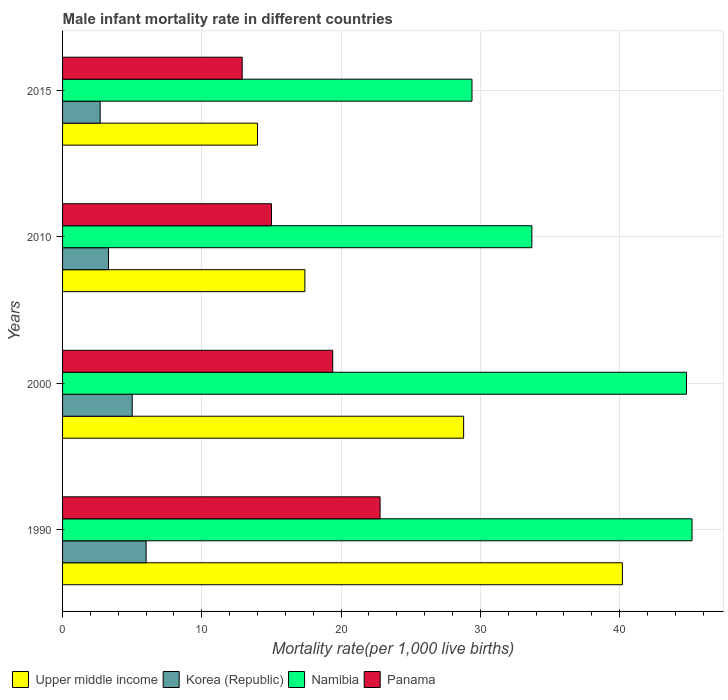How many different coloured bars are there?
Make the answer very short. 4. Are the number of bars per tick equal to the number of legend labels?
Give a very brief answer. Yes. How many bars are there on the 4th tick from the top?
Ensure brevity in your answer.  4. How many bars are there on the 1st tick from the bottom?
Keep it short and to the point. 4. In how many cases, is the number of bars for a given year not equal to the number of legend labels?
Give a very brief answer. 0. What is the male infant mortality rate in Namibia in 2000?
Your response must be concise. 44.8. Across all years, what is the maximum male infant mortality rate in Panama?
Give a very brief answer. 22.8. In which year was the male infant mortality rate in Upper middle income minimum?
Offer a very short reply. 2015. What is the total male infant mortality rate in Korea (Republic) in the graph?
Provide a short and direct response. 17. What is the difference between the male infant mortality rate in Namibia in 2000 and that in 2010?
Offer a terse response. 11.1. What is the difference between the male infant mortality rate in Panama in 2010 and the male infant mortality rate in Namibia in 2015?
Your answer should be very brief. -14.4. What is the average male infant mortality rate in Upper middle income per year?
Make the answer very short. 25.1. In the year 1990, what is the difference between the male infant mortality rate in Namibia and male infant mortality rate in Panama?
Give a very brief answer. 22.4. In how many years, is the male infant mortality rate in Upper middle income greater than 38 ?
Your answer should be very brief. 1. What is the ratio of the male infant mortality rate in Upper middle income in 1990 to that in 2015?
Keep it short and to the point. 2.87. Is the male infant mortality rate in Korea (Republic) in 1990 less than that in 2015?
Ensure brevity in your answer.  No. Is the difference between the male infant mortality rate in Namibia in 2000 and 2015 greater than the difference between the male infant mortality rate in Panama in 2000 and 2015?
Give a very brief answer. Yes. What is the difference between the highest and the second highest male infant mortality rate in Korea (Republic)?
Provide a succinct answer. 1. What is the difference between the highest and the lowest male infant mortality rate in Panama?
Offer a terse response. 9.9. In how many years, is the male infant mortality rate in Korea (Republic) greater than the average male infant mortality rate in Korea (Republic) taken over all years?
Your answer should be compact. 2. Is the sum of the male infant mortality rate in Korea (Republic) in 1990 and 2010 greater than the maximum male infant mortality rate in Panama across all years?
Provide a succinct answer. No. What does the 1st bar from the top in 2015 represents?
Keep it short and to the point. Panama. What does the 1st bar from the bottom in 2010 represents?
Keep it short and to the point. Upper middle income. Is it the case that in every year, the sum of the male infant mortality rate in Korea (Republic) and male infant mortality rate in Namibia is greater than the male infant mortality rate in Upper middle income?
Your answer should be compact. Yes. What is the difference between two consecutive major ticks on the X-axis?
Make the answer very short. 10. Are the values on the major ticks of X-axis written in scientific E-notation?
Offer a terse response. No. Does the graph contain any zero values?
Provide a short and direct response. No. Does the graph contain grids?
Your answer should be very brief. Yes. Where does the legend appear in the graph?
Give a very brief answer. Bottom left. How many legend labels are there?
Your response must be concise. 4. What is the title of the graph?
Provide a short and direct response. Male infant mortality rate in different countries. Does "Fragile and conflict affected situations" appear as one of the legend labels in the graph?
Provide a short and direct response. No. What is the label or title of the X-axis?
Give a very brief answer. Mortality rate(per 1,0 live births). What is the Mortality rate(per 1,000 live births) in Upper middle income in 1990?
Your answer should be very brief. 40.2. What is the Mortality rate(per 1,000 live births) in Namibia in 1990?
Your answer should be very brief. 45.2. What is the Mortality rate(per 1,000 live births) in Panama in 1990?
Your response must be concise. 22.8. What is the Mortality rate(per 1,000 live births) of Upper middle income in 2000?
Ensure brevity in your answer.  28.8. What is the Mortality rate(per 1,000 live births) in Namibia in 2000?
Keep it short and to the point. 44.8. What is the Mortality rate(per 1,000 live births) in Korea (Republic) in 2010?
Keep it short and to the point. 3.3. What is the Mortality rate(per 1,000 live births) in Namibia in 2010?
Keep it short and to the point. 33.7. What is the Mortality rate(per 1,000 live births) of Panama in 2010?
Offer a very short reply. 15. What is the Mortality rate(per 1,000 live births) of Namibia in 2015?
Provide a succinct answer. 29.4. What is the Mortality rate(per 1,000 live births) of Panama in 2015?
Keep it short and to the point. 12.9. Across all years, what is the maximum Mortality rate(per 1,000 live births) in Upper middle income?
Provide a succinct answer. 40.2. Across all years, what is the maximum Mortality rate(per 1,000 live births) in Namibia?
Make the answer very short. 45.2. Across all years, what is the maximum Mortality rate(per 1,000 live births) in Panama?
Keep it short and to the point. 22.8. Across all years, what is the minimum Mortality rate(per 1,000 live births) in Upper middle income?
Provide a succinct answer. 14. Across all years, what is the minimum Mortality rate(per 1,000 live births) in Korea (Republic)?
Your response must be concise. 2.7. Across all years, what is the minimum Mortality rate(per 1,000 live births) of Namibia?
Keep it short and to the point. 29.4. Across all years, what is the minimum Mortality rate(per 1,000 live births) in Panama?
Offer a very short reply. 12.9. What is the total Mortality rate(per 1,000 live births) of Upper middle income in the graph?
Your response must be concise. 100.4. What is the total Mortality rate(per 1,000 live births) in Namibia in the graph?
Offer a terse response. 153.1. What is the total Mortality rate(per 1,000 live births) in Panama in the graph?
Provide a succinct answer. 70.1. What is the difference between the Mortality rate(per 1,000 live births) in Upper middle income in 1990 and that in 2000?
Your response must be concise. 11.4. What is the difference between the Mortality rate(per 1,000 live births) of Namibia in 1990 and that in 2000?
Your answer should be compact. 0.4. What is the difference between the Mortality rate(per 1,000 live births) of Panama in 1990 and that in 2000?
Your answer should be very brief. 3.4. What is the difference between the Mortality rate(per 1,000 live births) in Upper middle income in 1990 and that in 2010?
Ensure brevity in your answer.  22.8. What is the difference between the Mortality rate(per 1,000 live births) in Korea (Republic) in 1990 and that in 2010?
Ensure brevity in your answer.  2.7. What is the difference between the Mortality rate(per 1,000 live births) in Namibia in 1990 and that in 2010?
Ensure brevity in your answer.  11.5. What is the difference between the Mortality rate(per 1,000 live births) of Upper middle income in 1990 and that in 2015?
Provide a short and direct response. 26.2. What is the difference between the Mortality rate(per 1,000 live births) in Namibia in 1990 and that in 2015?
Offer a very short reply. 15.8. What is the difference between the Mortality rate(per 1,000 live births) of Korea (Republic) in 2000 and that in 2010?
Provide a short and direct response. 1.7. What is the difference between the Mortality rate(per 1,000 live births) of Namibia in 2000 and that in 2010?
Give a very brief answer. 11.1. What is the difference between the Mortality rate(per 1,000 live births) of Panama in 2000 and that in 2010?
Your answer should be very brief. 4.4. What is the difference between the Mortality rate(per 1,000 live births) of Upper middle income in 2000 and that in 2015?
Your answer should be very brief. 14.8. What is the difference between the Mortality rate(per 1,000 live births) in Namibia in 2000 and that in 2015?
Offer a terse response. 15.4. What is the difference between the Mortality rate(per 1,000 live births) of Panama in 2000 and that in 2015?
Provide a succinct answer. 6.5. What is the difference between the Mortality rate(per 1,000 live births) of Korea (Republic) in 2010 and that in 2015?
Give a very brief answer. 0.6. What is the difference between the Mortality rate(per 1,000 live births) of Namibia in 2010 and that in 2015?
Keep it short and to the point. 4.3. What is the difference between the Mortality rate(per 1,000 live births) in Upper middle income in 1990 and the Mortality rate(per 1,000 live births) in Korea (Republic) in 2000?
Make the answer very short. 35.2. What is the difference between the Mortality rate(per 1,000 live births) of Upper middle income in 1990 and the Mortality rate(per 1,000 live births) of Panama in 2000?
Keep it short and to the point. 20.8. What is the difference between the Mortality rate(per 1,000 live births) in Korea (Republic) in 1990 and the Mortality rate(per 1,000 live births) in Namibia in 2000?
Provide a succinct answer. -38.8. What is the difference between the Mortality rate(per 1,000 live births) of Namibia in 1990 and the Mortality rate(per 1,000 live births) of Panama in 2000?
Your answer should be very brief. 25.8. What is the difference between the Mortality rate(per 1,000 live births) in Upper middle income in 1990 and the Mortality rate(per 1,000 live births) in Korea (Republic) in 2010?
Offer a terse response. 36.9. What is the difference between the Mortality rate(per 1,000 live births) of Upper middle income in 1990 and the Mortality rate(per 1,000 live births) of Namibia in 2010?
Your response must be concise. 6.5. What is the difference between the Mortality rate(per 1,000 live births) in Upper middle income in 1990 and the Mortality rate(per 1,000 live births) in Panama in 2010?
Give a very brief answer. 25.2. What is the difference between the Mortality rate(per 1,000 live births) of Korea (Republic) in 1990 and the Mortality rate(per 1,000 live births) of Namibia in 2010?
Make the answer very short. -27.7. What is the difference between the Mortality rate(per 1,000 live births) of Korea (Republic) in 1990 and the Mortality rate(per 1,000 live births) of Panama in 2010?
Provide a succinct answer. -9. What is the difference between the Mortality rate(per 1,000 live births) in Namibia in 1990 and the Mortality rate(per 1,000 live births) in Panama in 2010?
Keep it short and to the point. 30.2. What is the difference between the Mortality rate(per 1,000 live births) in Upper middle income in 1990 and the Mortality rate(per 1,000 live births) in Korea (Republic) in 2015?
Keep it short and to the point. 37.5. What is the difference between the Mortality rate(per 1,000 live births) in Upper middle income in 1990 and the Mortality rate(per 1,000 live births) in Namibia in 2015?
Make the answer very short. 10.8. What is the difference between the Mortality rate(per 1,000 live births) in Upper middle income in 1990 and the Mortality rate(per 1,000 live births) in Panama in 2015?
Ensure brevity in your answer.  27.3. What is the difference between the Mortality rate(per 1,000 live births) in Korea (Republic) in 1990 and the Mortality rate(per 1,000 live births) in Namibia in 2015?
Your response must be concise. -23.4. What is the difference between the Mortality rate(per 1,000 live births) of Namibia in 1990 and the Mortality rate(per 1,000 live births) of Panama in 2015?
Your answer should be compact. 32.3. What is the difference between the Mortality rate(per 1,000 live births) in Korea (Republic) in 2000 and the Mortality rate(per 1,000 live births) in Namibia in 2010?
Offer a terse response. -28.7. What is the difference between the Mortality rate(per 1,000 live births) of Namibia in 2000 and the Mortality rate(per 1,000 live births) of Panama in 2010?
Your answer should be compact. 29.8. What is the difference between the Mortality rate(per 1,000 live births) of Upper middle income in 2000 and the Mortality rate(per 1,000 live births) of Korea (Republic) in 2015?
Your answer should be very brief. 26.1. What is the difference between the Mortality rate(per 1,000 live births) of Upper middle income in 2000 and the Mortality rate(per 1,000 live births) of Panama in 2015?
Keep it short and to the point. 15.9. What is the difference between the Mortality rate(per 1,000 live births) in Korea (Republic) in 2000 and the Mortality rate(per 1,000 live births) in Namibia in 2015?
Your answer should be very brief. -24.4. What is the difference between the Mortality rate(per 1,000 live births) in Korea (Republic) in 2000 and the Mortality rate(per 1,000 live births) in Panama in 2015?
Offer a terse response. -7.9. What is the difference between the Mortality rate(per 1,000 live births) in Namibia in 2000 and the Mortality rate(per 1,000 live births) in Panama in 2015?
Keep it short and to the point. 31.9. What is the difference between the Mortality rate(per 1,000 live births) in Upper middle income in 2010 and the Mortality rate(per 1,000 live births) in Korea (Republic) in 2015?
Provide a succinct answer. 14.7. What is the difference between the Mortality rate(per 1,000 live births) in Upper middle income in 2010 and the Mortality rate(per 1,000 live births) in Panama in 2015?
Ensure brevity in your answer.  4.5. What is the difference between the Mortality rate(per 1,000 live births) in Korea (Republic) in 2010 and the Mortality rate(per 1,000 live births) in Namibia in 2015?
Your answer should be very brief. -26.1. What is the difference between the Mortality rate(per 1,000 live births) of Namibia in 2010 and the Mortality rate(per 1,000 live births) of Panama in 2015?
Your response must be concise. 20.8. What is the average Mortality rate(per 1,000 live births) of Upper middle income per year?
Your answer should be very brief. 25.1. What is the average Mortality rate(per 1,000 live births) in Korea (Republic) per year?
Your response must be concise. 4.25. What is the average Mortality rate(per 1,000 live births) of Namibia per year?
Provide a succinct answer. 38.27. What is the average Mortality rate(per 1,000 live births) of Panama per year?
Give a very brief answer. 17.52. In the year 1990, what is the difference between the Mortality rate(per 1,000 live births) of Upper middle income and Mortality rate(per 1,000 live births) of Korea (Republic)?
Ensure brevity in your answer.  34.2. In the year 1990, what is the difference between the Mortality rate(per 1,000 live births) of Upper middle income and Mortality rate(per 1,000 live births) of Panama?
Offer a very short reply. 17.4. In the year 1990, what is the difference between the Mortality rate(per 1,000 live births) of Korea (Republic) and Mortality rate(per 1,000 live births) of Namibia?
Your answer should be very brief. -39.2. In the year 1990, what is the difference between the Mortality rate(per 1,000 live births) of Korea (Republic) and Mortality rate(per 1,000 live births) of Panama?
Your response must be concise. -16.8. In the year 1990, what is the difference between the Mortality rate(per 1,000 live births) in Namibia and Mortality rate(per 1,000 live births) in Panama?
Give a very brief answer. 22.4. In the year 2000, what is the difference between the Mortality rate(per 1,000 live births) in Upper middle income and Mortality rate(per 1,000 live births) in Korea (Republic)?
Offer a very short reply. 23.8. In the year 2000, what is the difference between the Mortality rate(per 1,000 live births) in Upper middle income and Mortality rate(per 1,000 live births) in Namibia?
Your answer should be compact. -16. In the year 2000, what is the difference between the Mortality rate(per 1,000 live births) of Korea (Republic) and Mortality rate(per 1,000 live births) of Namibia?
Make the answer very short. -39.8. In the year 2000, what is the difference between the Mortality rate(per 1,000 live births) of Korea (Republic) and Mortality rate(per 1,000 live births) of Panama?
Ensure brevity in your answer.  -14.4. In the year 2000, what is the difference between the Mortality rate(per 1,000 live births) in Namibia and Mortality rate(per 1,000 live births) in Panama?
Provide a succinct answer. 25.4. In the year 2010, what is the difference between the Mortality rate(per 1,000 live births) in Upper middle income and Mortality rate(per 1,000 live births) in Korea (Republic)?
Your answer should be compact. 14.1. In the year 2010, what is the difference between the Mortality rate(per 1,000 live births) of Upper middle income and Mortality rate(per 1,000 live births) of Namibia?
Provide a succinct answer. -16.3. In the year 2010, what is the difference between the Mortality rate(per 1,000 live births) of Korea (Republic) and Mortality rate(per 1,000 live births) of Namibia?
Provide a succinct answer. -30.4. In the year 2015, what is the difference between the Mortality rate(per 1,000 live births) of Upper middle income and Mortality rate(per 1,000 live births) of Korea (Republic)?
Provide a succinct answer. 11.3. In the year 2015, what is the difference between the Mortality rate(per 1,000 live births) of Upper middle income and Mortality rate(per 1,000 live births) of Namibia?
Keep it short and to the point. -15.4. In the year 2015, what is the difference between the Mortality rate(per 1,000 live births) in Korea (Republic) and Mortality rate(per 1,000 live births) in Namibia?
Your response must be concise. -26.7. In the year 2015, what is the difference between the Mortality rate(per 1,000 live births) of Korea (Republic) and Mortality rate(per 1,000 live births) of Panama?
Your answer should be compact. -10.2. What is the ratio of the Mortality rate(per 1,000 live births) in Upper middle income in 1990 to that in 2000?
Offer a terse response. 1.4. What is the ratio of the Mortality rate(per 1,000 live births) in Namibia in 1990 to that in 2000?
Ensure brevity in your answer.  1.01. What is the ratio of the Mortality rate(per 1,000 live births) in Panama in 1990 to that in 2000?
Offer a very short reply. 1.18. What is the ratio of the Mortality rate(per 1,000 live births) of Upper middle income in 1990 to that in 2010?
Your answer should be very brief. 2.31. What is the ratio of the Mortality rate(per 1,000 live births) of Korea (Republic) in 1990 to that in 2010?
Offer a terse response. 1.82. What is the ratio of the Mortality rate(per 1,000 live births) in Namibia in 1990 to that in 2010?
Ensure brevity in your answer.  1.34. What is the ratio of the Mortality rate(per 1,000 live births) in Panama in 1990 to that in 2010?
Your answer should be compact. 1.52. What is the ratio of the Mortality rate(per 1,000 live births) of Upper middle income in 1990 to that in 2015?
Give a very brief answer. 2.87. What is the ratio of the Mortality rate(per 1,000 live births) in Korea (Republic) in 1990 to that in 2015?
Give a very brief answer. 2.22. What is the ratio of the Mortality rate(per 1,000 live births) in Namibia in 1990 to that in 2015?
Provide a succinct answer. 1.54. What is the ratio of the Mortality rate(per 1,000 live births) in Panama in 1990 to that in 2015?
Your answer should be compact. 1.77. What is the ratio of the Mortality rate(per 1,000 live births) in Upper middle income in 2000 to that in 2010?
Provide a succinct answer. 1.66. What is the ratio of the Mortality rate(per 1,000 live births) in Korea (Republic) in 2000 to that in 2010?
Your answer should be very brief. 1.52. What is the ratio of the Mortality rate(per 1,000 live births) in Namibia in 2000 to that in 2010?
Provide a succinct answer. 1.33. What is the ratio of the Mortality rate(per 1,000 live births) of Panama in 2000 to that in 2010?
Make the answer very short. 1.29. What is the ratio of the Mortality rate(per 1,000 live births) in Upper middle income in 2000 to that in 2015?
Provide a short and direct response. 2.06. What is the ratio of the Mortality rate(per 1,000 live births) in Korea (Republic) in 2000 to that in 2015?
Your answer should be very brief. 1.85. What is the ratio of the Mortality rate(per 1,000 live births) in Namibia in 2000 to that in 2015?
Give a very brief answer. 1.52. What is the ratio of the Mortality rate(per 1,000 live births) in Panama in 2000 to that in 2015?
Keep it short and to the point. 1.5. What is the ratio of the Mortality rate(per 1,000 live births) in Upper middle income in 2010 to that in 2015?
Provide a short and direct response. 1.24. What is the ratio of the Mortality rate(per 1,000 live births) in Korea (Republic) in 2010 to that in 2015?
Give a very brief answer. 1.22. What is the ratio of the Mortality rate(per 1,000 live births) of Namibia in 2010 to that in 2015?
Provide a short and direct response. 1.15. What is the ratio of the Mortality rate(per 1,000 live births) of Panama in 2010 to that in 2015?
Offer a terse response. 1.16. What is the difference between the highest and the second highest Mortality rate(per 1,000 live births) of Namibia?
Offer a very short reply. 0.4. What is the difference between the highest and the lowest Mortality rate(per 1,000 live births) in Upper middle income?
Provide a short and direct response. 26.2. What is the difference between the highest and the lowest Mortality rate(per 1,000 live births) of Korea (Republic)?
Your answer should be compact. 3.3. What is the difference between the highest and the lowest Mortality rate(per 1,000 live births) of Namibia?
Ensure brevity in your answer.  15.8. What is the difference between the highest and the lowest Mortality rate(per 1,000 live births) of Panama?
Ensure brevity in your answer.  9.9. 